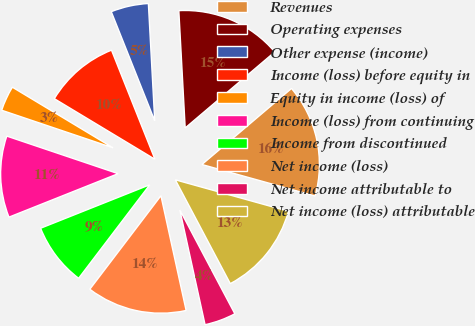<chart> <loc_0><loc_0><loc_500><loc_500><pie_chart><fcel>Revenues<fcel>Operating expenses<fcel>Other expense (income)<fcel>Income (loss) before equity in<fcel>Equity in income (loss) of<fcel>Income (loss) from continuing<fcel>Income from discontinued<fcel>Net income (loss)<fcel>Net income attributable to<fcel>Net income (loss) attributable<nl><fcel>15.52%<fcel>14.66%<fcel>5.17%<fcel>10.34%<fcel>3.45%<fcel>11.21%<fcel>8.62%<fcel>13.79%<fcel>4.31%<fcel>12.93%<nl></chart> 